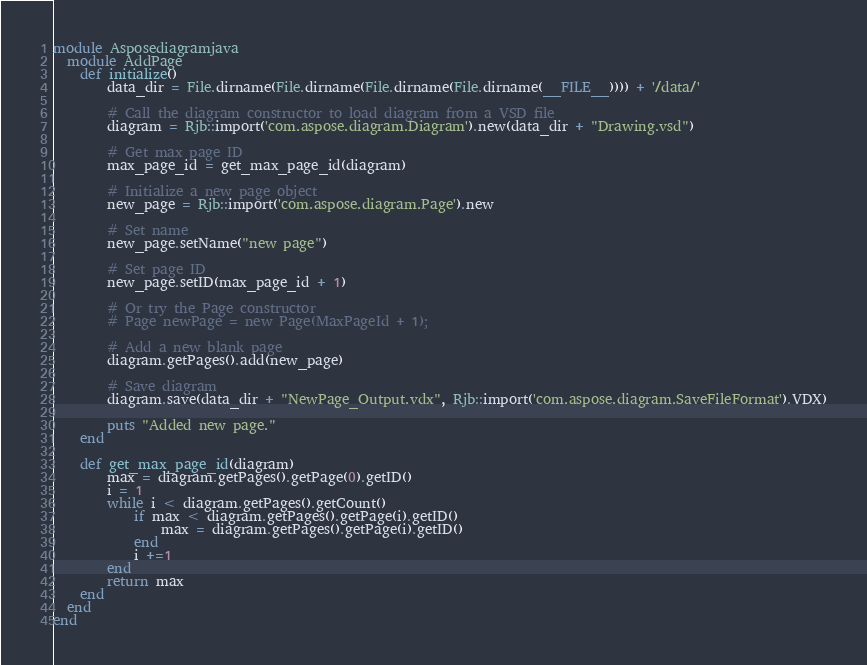<code> <loc_0><loc_0><loc_500><loc_500><_Ruby_>module Asposediagramjava
  module AddPage
    def initialize()
        data_dir = File.dirname(File.dirname(File.dirname(File.dirname(__FILE__)))) + '/data/'

        # Call the diagram constructor to load diagram from a VSD file
        diagram = Rjb::import('com.aspose.diagram.Diagram').new(data_dir + "Drawing.vsd")

        # Get max page ID
        max_page_id = get_max_page_id(diagram)

        # Initialize a new page object
        new_page = Rjb::import('com.aspose.diagram.Page').new

        # Set name
        new_page.setName("new page")
        
        # Set page ID
        new_page.setID(max_page_id + 1)

        # Or try the Page constructor
        # Page newPage = new Page(MaxPageId + 1);

        # Add a new blank page
        diagram.getPages().add(new_page)

        # Save diagram
        diagram.save(data_dir + "NewPage_Output.vdx", Rjb::import('com.aspose.diagram.SaveFileFormat').VDX)

        puts "Added new page."
    end

    def get_max_page_id(diagram)
        max = diagram.getPages().getPage(0).getID()
        i = 1
        while i < diagram.getPages().getCount()
            if max < diagram.getPages().getPage(i).getID()
                max = diagram.getPages().getPage(i).getID()
            end
            i +=1
        end
        return max
    end
  end
end
</code> 